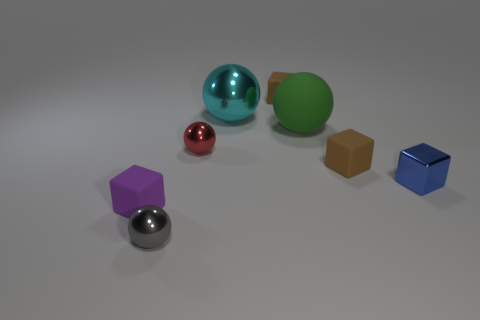Add 1 large green metal balls. How many objects exist? 9 Subtract all shiny balls. How many balls are left? 1 Subtract all brown cylinders. How many brown blocks are left? 2 Subtract all red balls. How many balls are left? 3 Subtract 2 cubes. How many cubes are left? 2 Subtract 0 red cylinders. How many objects are left? 8 Subtract all gray blocks. Subtract all brown cylinders. How many blocks are left? 4 Subtract all balls. Subtract all big metal objects. How many objects are left? 3 Add 5 small blue objects. How many small blue objects are left? 6 Add 5 large cyan spheres. How many large cyan spheres exist? 6 